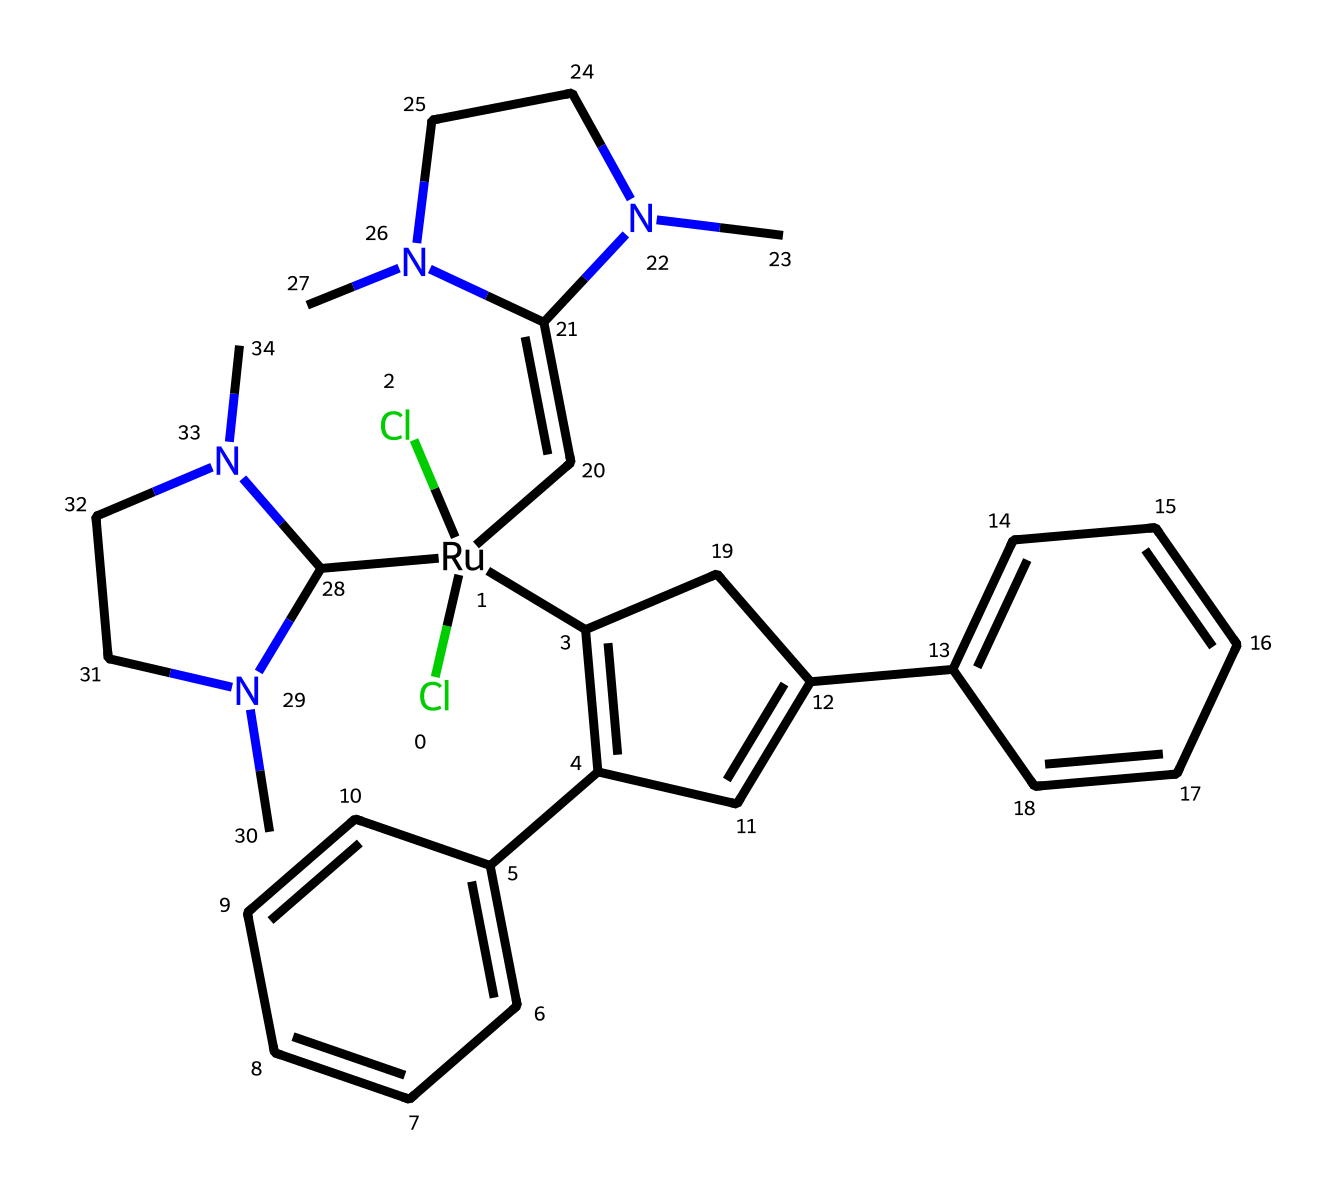What metal is central to the structure of this catalyst? The central metal in the structure is ruthenium, indicated by the symbol [Ru] in the SMILES representation.
Answer: ruthenium How many chlorine atoms are present in the chemical structure? By analyzing the SMILES, there are two instances of 'Cl', indicating two chlorine atoms are present in the structure.
Answer: two What type of reaction is this catalyst primarily used for? The context of the chemical indicates it is used for olefin metathesis, which involves the exchange of alkene partners.
Answer: olefin metathesis How many nitrogen atoms are in the molecule? In the SMILES, 'N' appears three times throughout the structure, indicating there are three nitrogen atoms in total.
Answer: three Which functional group is present in this structure that indicates its organometallic nature? The presence of the metal-bound carbon (the C=C bond attached directly to ruthenium) signifies that it is an organometallic complex.
Answer: metal-bound carbon What is the total number of cyclic structures in the molecule? The SMILES representation contains three cyclical structures: one contained within the large ring and two phenyl groups (attached to the ring), making a total of three.
Answer: three 